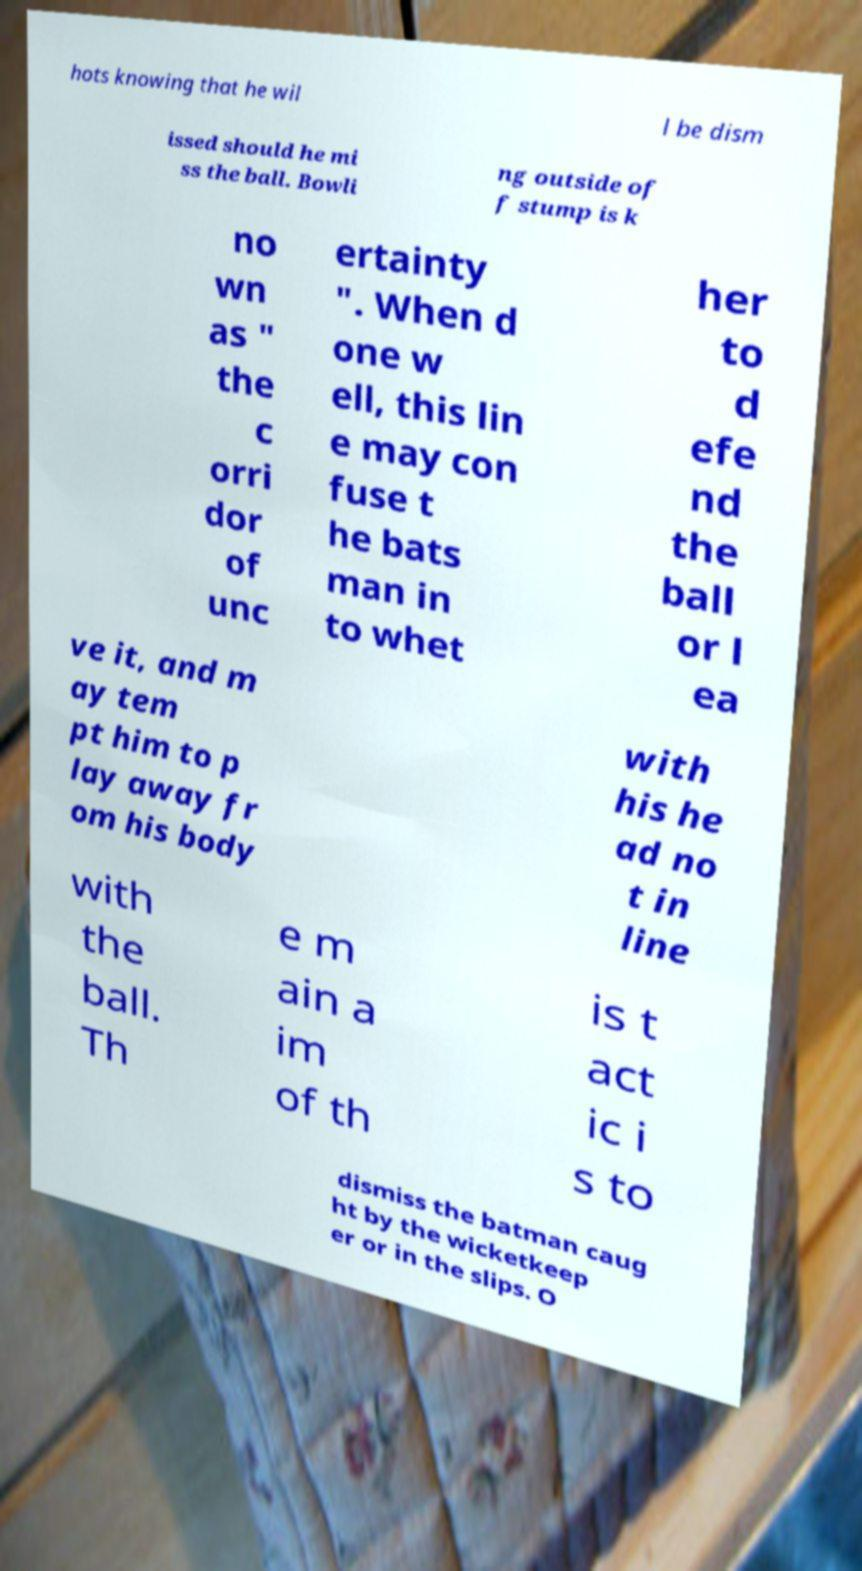For documentation purposes, I need the text within this image transcribed. Could you provide that? hots knowing that he wil l be dism issed should he mi ss the ball. Bowli ng outside of f stump is k no wn as " the c orri dor of unc ertainty ". When d one w ell, this lin e may con fuse t he bats man in to whet her to d efe nd the ball or l ea ve it, and m ay tem pt him to p lay away fr om his body with his he ad no t in line with the ball. Th e m ain a im of th is t act ic i s to dismiss the batman caug ht by the wicketkeep er or in the slips. O 